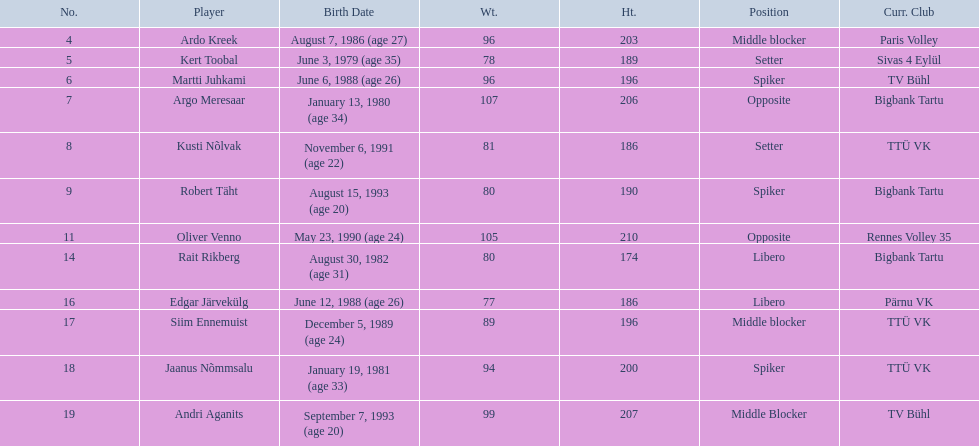What are the heights in cm of the men on the team? 203, 189, 196, 206, 186, 190, 210, 174, 186, 196, 200, 207. What is the tallest height of a team member? 210. Which player stands at 210? Oliver Venno. 